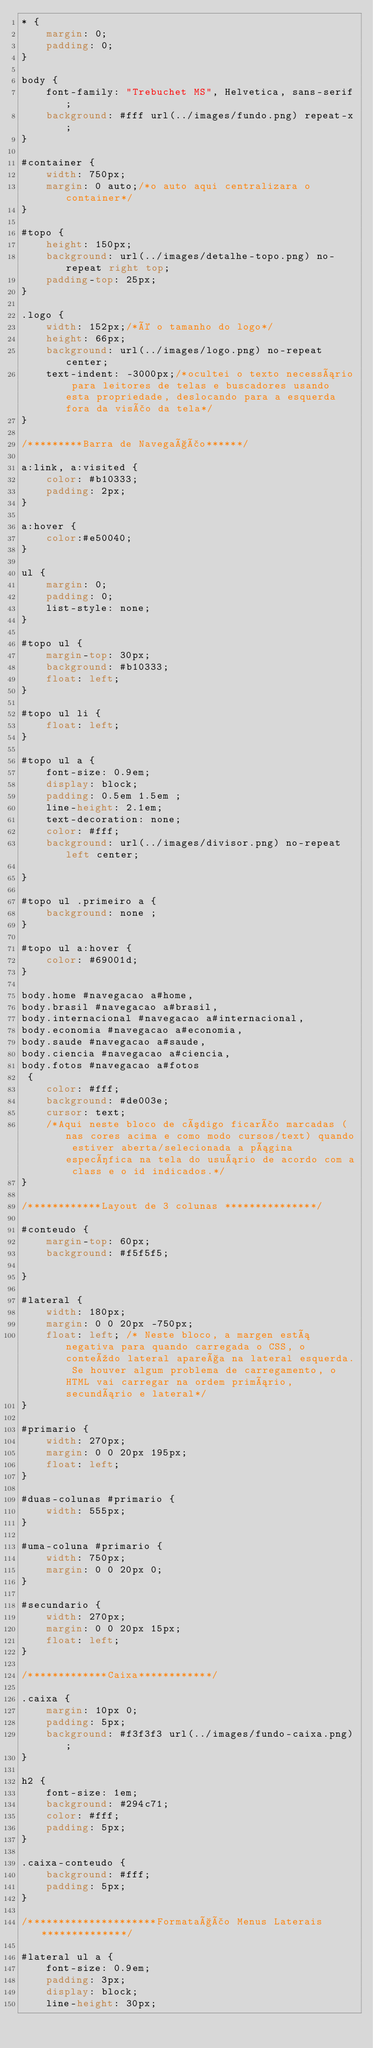<code> <loc_0><loc_0><loc_500><loc_500><_CSS_>* {
    margin: 0;
    padding: 0;
}

body {
    font-family: "Trebuchet MS", Helvetica, sans-serif;
    background: #fff url(../images/fundo.png) repeat-x;
}

#container {
    width: 750px;
    margin: 0 auto;/*o auto aqui centralizara o container*/
}

#topo {
    height: 150px;
    background: url(../images/detalhe-topo.png) no-repeat right top;
    padding-top: 25px;
}

.logo {
    width: 152px;/*é o tamanho do logo*/
    height: 66px;
    background: url(../images/logo.png) no-repeat center;
    text-indent: -3000px;/*ocultei o texto necessário para leitores de telas e buscadores usando esta propriedade, deslocando para a esquerda fora da visão da tela*/
}

/*********Barra de Navegação******/

a:link, a:visited {
    color: #b10333;
    padding: 2px;
}

a:hover {
    color:#e50040;
}

ul {
    margin: 0;
    padding: 0;
    list-style: none;
}

#topo ul {
    margin-top: 30px;
    background: #b10333;
    float: left;
}

#topo ul li {
    float: left;
}

#topo ul a {
    font-size: 0.9em;
    display: block;
    padding: 0.5em 1.5em ;
    line-height: 2.1em;
    text-decoration: none;
    color: #fff;
    background: url(../images/divisor.png) no-repeat left center;
    
}

#topo ul .primeiro a {
    background: none ;
}

#topo ul a:hover {
    color: #69001d;
}

body.home #navegacao a#home,
body.brasil #navegacao a#brasil,
body.internacional #navegacao a#internacional,
body.economia #navegacao a#economia,
body.saude #navegacao a#saude,
body.ciencia #navegacao a#ciencia,
body.fotos #navegacao a#fotos
 {
    color: #fff;
    background: #de003e;
    cursor: text;
    /*Aqui neste bloco de código ficarão marcadas (nas cores acima e como modo cursos/text) quando estiver aberta/selecionada a página específica na tela do usuário de acordo com a class e o id indicados.*/
}

/************Layout de 3 colunas ***************/

#conteudo {
    margin-top: 60px;
    background: #f5f5f5;

}

#lateral {
    width: 180px;
    margin: 0 0 20px -750px;
    float: left; /* Neste bloco, a margen está negativa para quando carregada o CSS, o conteúdo lateral apareça na lateral esquerda. Se houver algum problema de carregamento, o HTML vai carregar na ordem primário, secundário e lateral*/
}

#primario {
    width: 270px;
    margin: 0 0 20px 195px;
    float: left;
}

#duas-colunas #primario {
    width: 555px;
}

#uma-coluna #primario {
    width: 750px;
    margin: 0 0 20px 0;
}

#secundario {
    width: 270px;
    margin: 0 0 20px 15px;
    float: left;
}

/*************Caixa************/

.caixa {
    margin: 10px 0;
    padding: 5px;
    background: #f3f3f3 url(../images/fundo-caixa.png);
}

h2 {
    font-size: 1em;
    background: #294c71;
    color: #fff;
    padding: 5px;
}

.caixa-conteudo {
    background: #fff;
    padding: 5px;
}

/*********************Formatação Menus Laterais**************/

#lateral ul a {
    font-size: 0.9em;
    padding: 3px;
    display: block;
    line-height: 30px;</code> 